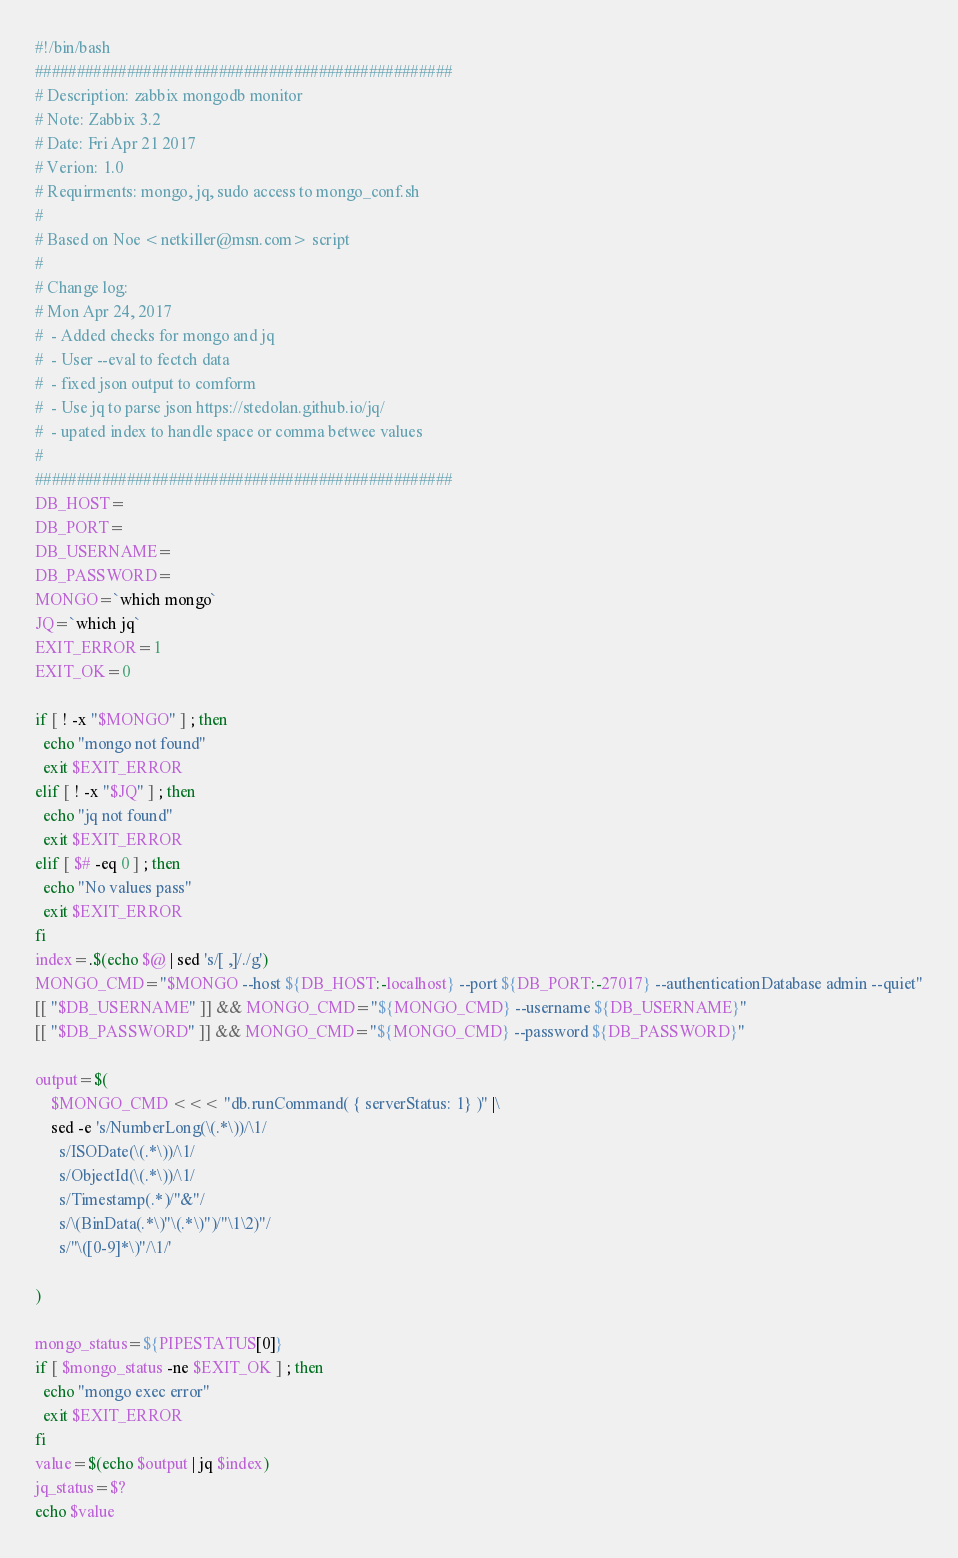<code> <loc_0><loc_0><loc_500><loc_500><_Bash_>#!/bin/bash
##################################################
# Description: zabbix mongodb monitor
# Note: Zabbix 3.2
# Date: Fri Apr 21 2017
# Verion: 1.0
# Requirments: mongo, jq, sudo access to mongo_conf.sh
#
# Based on Noe <netkiller@msn.com> script
#
# Change log:
# Mon Apr 24, 2017
#  - Added checks for mongo and jq
#  - User --eval to fectch data
#  - fixed json output to comform
#  - Use jq to parse json https://stedolan.github.io/jq/
#  - upated index to handle space or comma betwee values
# 
##################################################
DB_HOST=
DB_PORT=
DB_USERNAME=
DB_PASSWORD=
MONGO=`which mongo`
JQ=`which jq`
EXIT_ERROR=1
EXIT_OK=0

if [ ! -x "$MONGO" ] ; then
  echo "mongo not found"
  exit $EXIT_ERROR
elif [ ! -x "$JQ" ] ; then
  echo "jq not found"
  exit $EXIT_ERROR
elif [ $# -eq 0 ] ; then
  echo "No values pass"
  exit $EXIT_ERROR
fi
index=.$(echo $@ | sed 's/[ ,]/./g')
MONGO_CMD="$MONGO --host ${DB_HOST:-localhost} --port ${DB_PORT:-27017} --authenticationDatabase admin --quiet"
[[ "$DB_USERNAME" ]] && MONGO_CMD="${MONGO_CMD} --username ${DB_USERNAME}"
[[ "$DB_PASSWORD" ]] && MONGO_CMD="${MONGO_CMD} --password ${DB_PASSWORD}"

output=$(
	$MONGO_CMD <<< "db.runCommand( { serverStatus: 1} )" |\
	sed -e 's/NumberLong(\(.*\))/\1/ 
	  s/ISODate(\(.*\))/\1/
	  s/ObjectId(\(.*\))/\1/
	  s/Timestamp(.*)/"&"/
	  s/\(BinData(.*\)"\(.*\)")/"\1\2)"/
	  s/"\([0-9]*\)"/\1/' 
	 
)

mongo_status=${PIPESTATUS[0]}
if [ $mongo_status -ne $EXIT_OK ] ; then
  echo "mongo exec error"
  exit $EXIT_ERROR
fi
value=$(echo $output | jq $index)
jq_status=$?
echo $value

</code> 